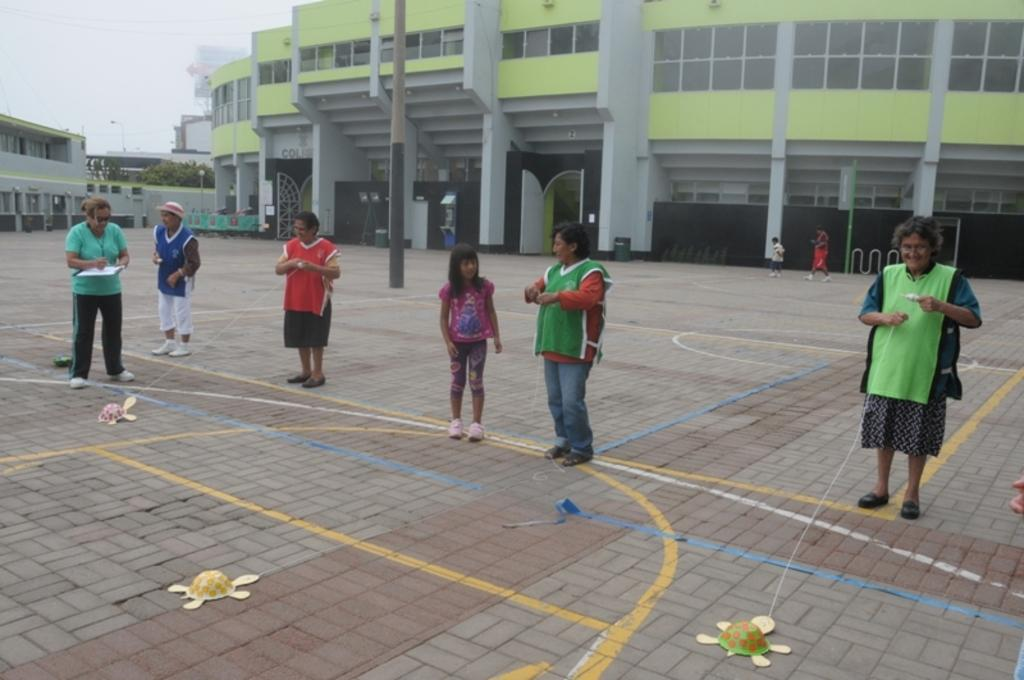What type of structures can be seen in the image? There are buildings in the image. What natural element is present in the image? There is a tree in the image. What are some of the people in the image doing? Some people are walking, while others are standing and holding strings. What objects are on the ground in the image? There are toys on the ground. What is the human holding in the image? The human is holding papers in the image. What type of fruit is hanging from the tree in the image? There is no fruit visible on the tree in the image. What valuable jewels can be seen on the ground in the image? There are no jewels present in the image; it features toys on the ground. 